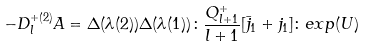<formula> <loc_0><loc_0><loc_500><loc_500>- D _ { l } ^ { + ( 2 ) } A = \Delta ( \lambda ( 2 ) ) \Delta ( \lambda ( 1 ) ) \colon \frac { Q _ { l + 1 } ^ { + } } { l + 1 } [ \bar { j } _ { 1 } + j _ { 1 } ] \colon e x p ( U )</formula> 